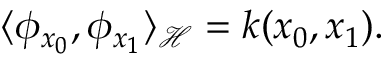<formula> <loc_0><loc_0><loc_500><loc_500>\langle \phi _ { x _ { 0 } } , \phi _ { x _ { 1 } } \rangle _ { \mathcal { H } } = k ( x _ { 0 } , x _ { 1 } ) .</formula> 